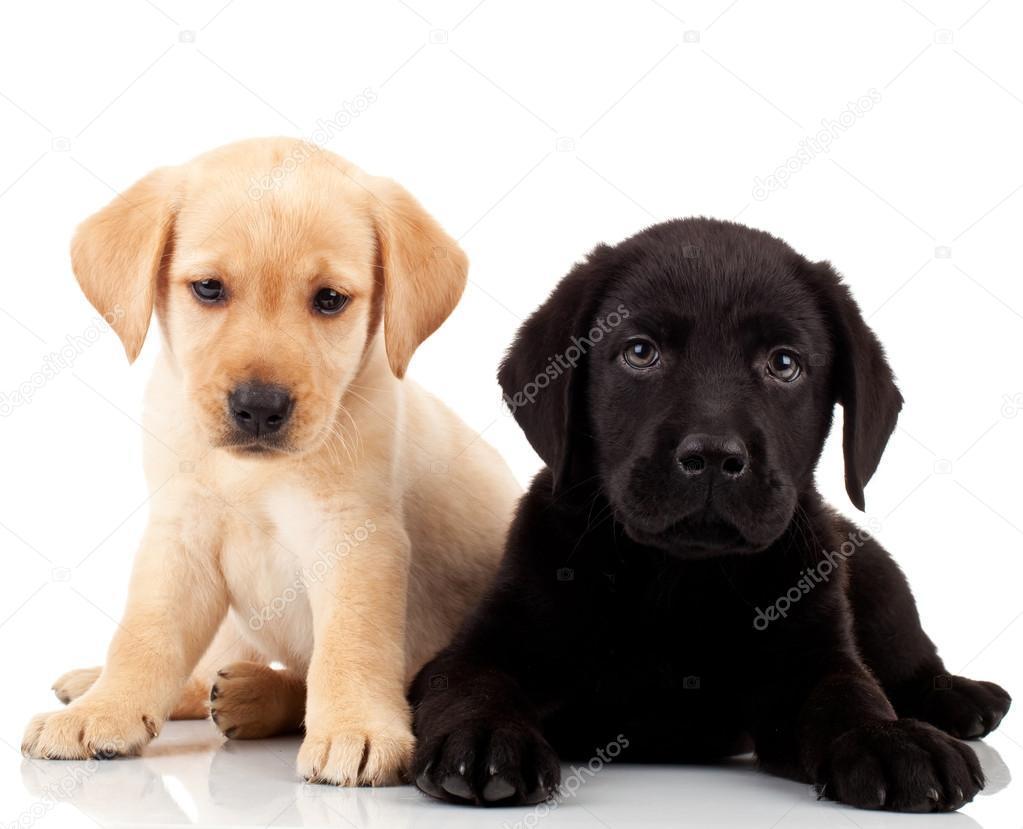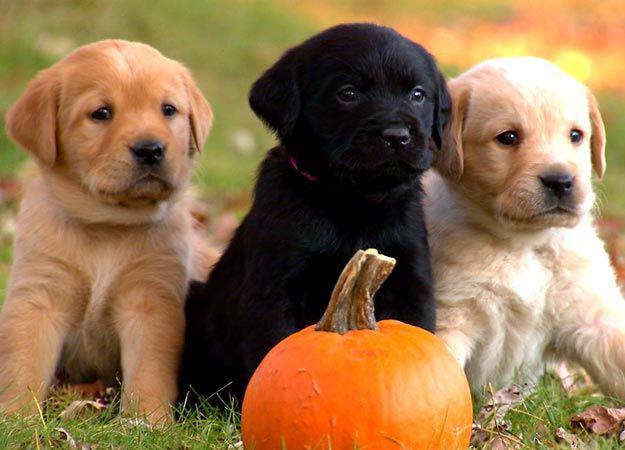The first image is the image on the left, the second image is the image on the right. Given the left and right images, does the statement "Two tan dogs and a black dog pose together in the image on the right." hold true? Answer yes or no. Yes. The first image is the image on the left, the second image is the image on the right. Assess this claim about the two images: "An image contains one black puppy to the left of one tan puppy, and contains only two puppies.". Correct or not? Answer yes or no. No. 